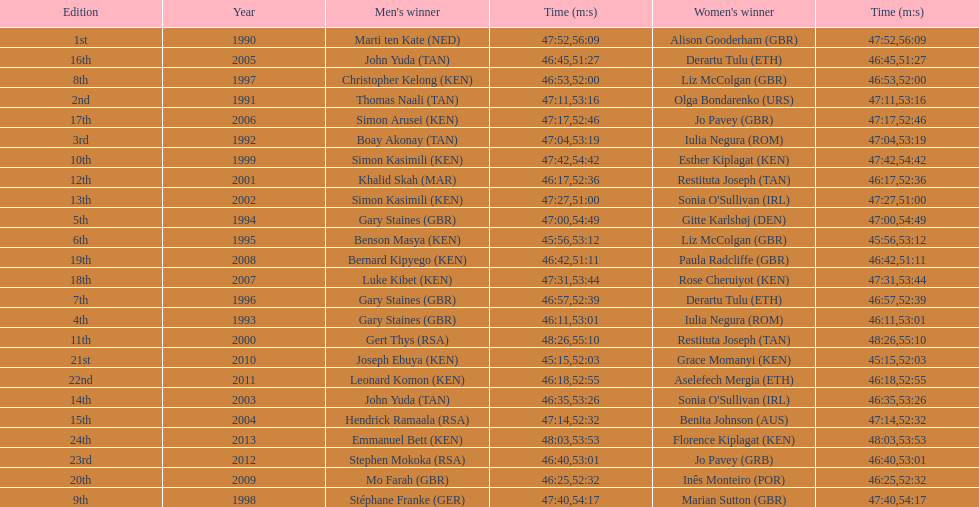Who is the male winner listed before gert thys? Simon Kasimili. 